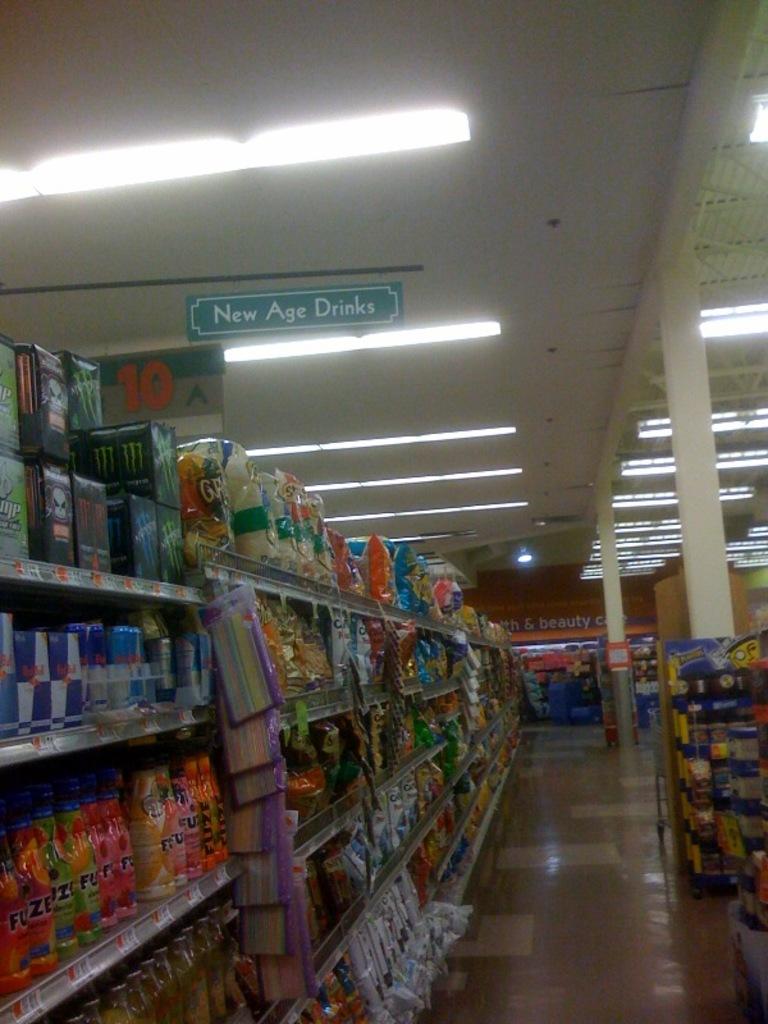What is this aisle selling?
Your answer should be compact. New age drinks. Which aisle number are we in?
Your answer should be compact. 10. 